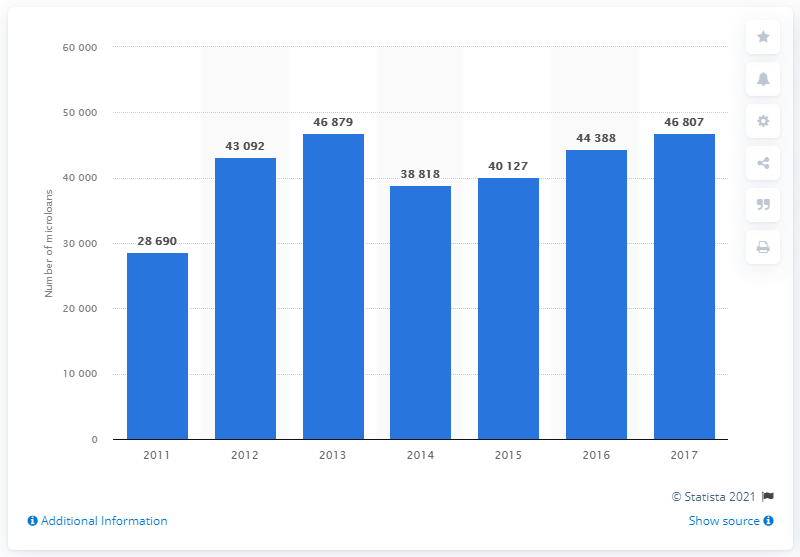Point out several critical features in this image. During the period of 2011 to 2017, a total of 46,807 microloans were disbursed on the French microfinance market. 